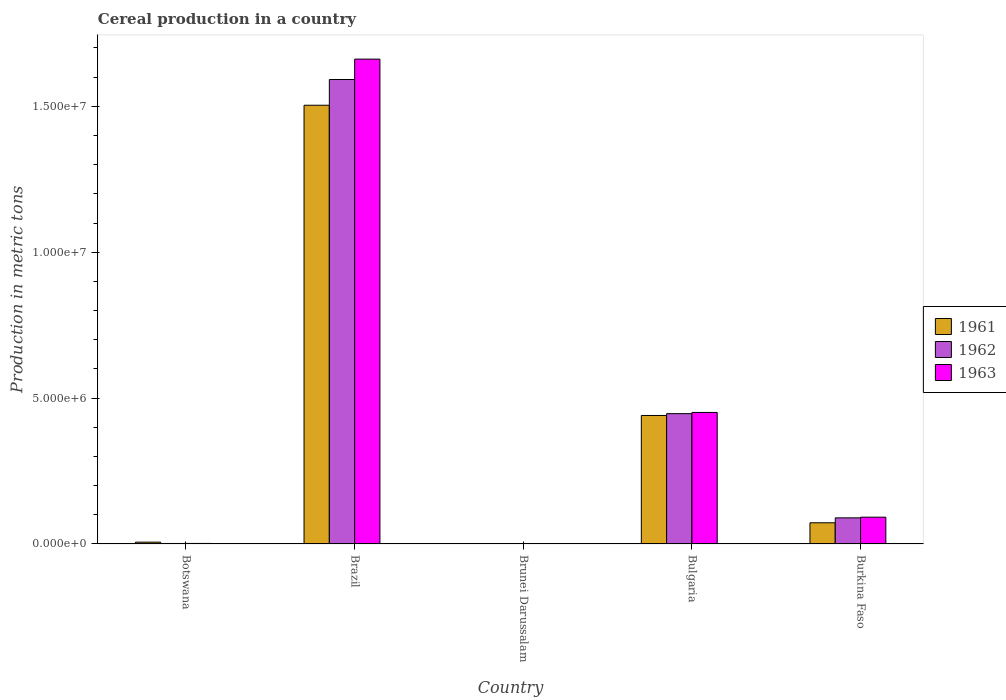Are the number of bars per tick equal to the number of legend labels?
Your response must be concise. Yes. Are the number of bars on each tick of the X-axis equal?
Offer a terse response. Yes. What is the label of the 5th group of bars from the left?
Keep it short and to the point. Burkina Faso. What is the total cereal production in 1963 in Brunei Darussalam?
Your answer should be very brief. 3868. Across all countries, what is the maximum total cereal production in 1962?
Offer a very short reply. 1.59e+07. Across all countries, what is the minimum total cereal production in 1962?
Ensure brevity in your answer.  5245. In which country was the total cereal production in 1963 minimum?
Your answer should be compact. Brunei Darussalam. What is the total total cereal production in 1961 in the graph?
Ensure brevity in your answer.  2.02e+07. What is the difference between the total cereal production in 1961 in Brazil and that in Bulgaria?
Provide a succinct answer. 1.06e+07. What is the difference between the total cereal production in 1962 in Burkina Faso and the total cereal production in 1961 in Brazil?
Your answer should be very brief. -1.41e+07. What is the average total cereal production in 1961 per country?
Your answer should be compact. 4.05e+06. What is the difference between the total cereal production of/in 1962 and total cereal production of/in 1961 in Brunei Darussalam?
Your answer should be very brief. 337. In how many countries, is the total cereal production in 1962 greater than 9000000 metric tons?
Provide a succinct answer. 1. What is the ratio of the total cereal production in 1963 in Botswana to that in Brazil?
Your answer should be very brief. 0. Is the difference between the total cereal production in 1962 in Brunei Darussalam and Burkina Faso greater than the difference between the total cereal production in 1961 in Brunei Darussalam and Burkina Faso?
Offer a very short reply. No. What is the difference between the highest and the second highest total cereal production in 1963?
Ensure brevity in your answer.  3.59e+06. What is the difference between the highest and the lowest total cereal production in 1961?
Make the answer very short. 1.50e+07. Is the sum of the total cereal production in 1962 in Brunei Darussalam and Bulgaria greater than the maximum total cereal production in 1961 across all countries?
Ensure brevity in your answer.  No. What does the 3rd bar from the left in Botswana represents?
Offer a terse response. 1963. How many countries are there in the graph?
Offer a very short reply. 5. What is the difference between two consecutive major ticks on the Y-axis?
Offer a very short reply. 5.00e+06. Are the values on the major ticks of Y-axis written in scientific E-notation?
Give a very brief answer. Yes. Where does the legend appear in the graph?
Your answer should be compact. Center right. How many legend labels are there?
Your answer should be very brief. 3. What is the title of the graph?
Provide a succinct answer. Cereal production in a country. Does "2004" appear as one of the legend labels in the graph?
Offer a very short reply. No. What is the label or title of the X-axis?
Provide a succinct answer. Country. What is the label or title of the Y-axis?
Your answer should be compact. Production in metric tons. What is the Production in metric tons of 1961 in Botswana?
Provide a succinct answer. 6.22e+04. What is the Production in metric tons in 1962 in Botswana?
Make the answer very short. 1.69e+04. What is the Production in metric tons in 1963 in Botswana?
Your response must be concise. 1.86e+04. What is the Production in metric tons of 1961 in Brazil?
Offer a terse response. 1.50e+07. What is the Production in metric tons in 1962 in Brazil?
Provide a succinct answer. 1.59e+07. What is the Production in metric tons in 1963 in Brazil?
Give a very brief answer. 1.66e+07. What is the Production in metric tons of 1961 in Brunei Darussalam?
Give a very brief answer. 4908. What is the Production in metric tons of 1962 in Brunei Darussalam?
Your answer should be compact. 5245. What is the Production in metric tons in 1963 in Brunei Darussalam?
Provide a short and direct response. 3868. What is the Production in metric tons of 1961 in Bulgaria?
Keep it short and to the point. 4.40e+06. What is the Production in metric tons in 1962 in Bulgaria?
Offer a very short reply. 4.47e+06. What is the Production in metric tons in 1963 in Bulgaria?
Offer a terse response. 4.51e+06. What is the Production in metric tons of 1961 in Burkina Faso?
Provide a short and direct response. 7.26e+05. What is the Production in metric tons in 1962 in Burkina Faso?
Offer a very short reply. 8.95e+05. What is the Production in metric tons of 1963 in Burkina Faso?
Provide a succinct answer. 9.18e+05. Across all countries, what is the maximum Production in metric tons in 1961?
Your answer should be compact. 1.50e+07. Across all countries, what is the maximum Production in metric tons in 1962?
Provide a short and direct response. 1.59e+07. Across all countries, what is the maximum Production in metric tons in 1963?
Offer a terse response. 1.66e+07. Across all countries, what is the minimum Production in metric tons of 1961?
Your response must be concise. 4908. Across all countries, what is the minimum Production in metric tons in 1962?
Provide a succinct answer. 5245. Across all countries, what is the minimum Production in metric tons in 1963?
Your answer should be very brief. 3868. What is the total Production in metric tons of 1961 in the graph?
Offer a very short reply. 2.02e+07. What is the total Production in metric tons in 1962 in the graph?
Make the answer very short. 2.13e+07. What is the total Production in metric tons in 1963 in the graph?
Offer a very short reply. 2.21e+07. What is the difference between the Production in metric tons in 1961 in Botswana and that in Brazil?
Offer a very short reply. -1.50e+07. What is the difference between the Production in metric tons in 1962 in Botswana and that in Brazil?
Ensure brevity in your answer.  -1.59e+07. What is the difference between the Production in metric tons of 1963 in Botswana and that in Brazil?
Your response must be concise. -1.66e+07. What is the difference between the Production in metric tons in 1961 in Botswana and that in Brunei Darussalam?
Make the answer very short. 5.73e+04. What is the difference between the Production in metric tons of 1962 in Botswana and that in Brunei Darussalam?
Your answer should be compact. 1.17e+04. What is the difference between the Production in metric tons of 1963 in Botswana and that in Brunei Darussalam?
Ensure brevity in your answer.  1.47e+04. What is the difference between the Production in metric tons of 1961 in Botswana and that in Bulgaria?
Provide a short and direct response. -4.34e+06. What is the difference between the Production in metric tons of 1962 in Botswana and that in Bulgaria?
Offer a terse response. -4.45e+06. What is the difference between the Production in metric tons of 1963 in Botswana and that in Bulgaria?
Provide a succinct answer. -4.49e+06. What is the difference between the Production in metric tons of 1961 in Botswana and that in Burkina Faso?
Provide a short and direct response. -6.64e+05. What is the difference between the Production in metric tons in 1962 in Botswana and that in Burkina Faso?
Ensure brevity in your answer.  -8.78e+05. What is the difference between the Production in metric tons in 1963 in Botswana and that in Burkina Faso?
Your answer should be compact. -9.00e+05. What is the difference between the Production in metric tons in 1961 in Brazil and that in Brunei Darussalam?
Offer a terse response. 1.50e+07. What is the difference between the Production in metric tons in 1962 in Brazil and that in Brunei Darussalam?
Offer a terse response. 1.59e+07. What is the difference between the Production in metric tons in 1963 in Brazil and that in Brunei Darussalam?
Make the answer very short. 1.66e+07. What is the difference between the Production in metric tons of 1961 in Brazil and that in Bulgaria?
Your answer should be compact. 1.06e+07. What is the difference between the Production in metric tons in 1962 in Brazil and that in Bulgaria?
Your answer should be compact. 1.15e+07. What is the difference between the Production in metric tons in 1963 in Brazil and that in Bulgaria?
Ensure brevity in your answer.  1.21e+07. What is the difference between the Production in metric tons in 1961 in Brazil and that in Burkina Faso?
Provide a succinct answer. 1.43e+07. What is the difference between the Production in metric tons of 1962 in Brazil and that in Burkina Faso?
Your answer should be compact. 1.50e+07. What is the difference between the Production in metric tons of 1963 in Brazil and that in Burkina Faso?
Your answer should be compact. 1.57e+07. What is the difference between the Production in metric tons in 1961 in Brunei Darussalam and that in Bulgaria?
Offer a terse response. -4.40e+06. What is the difference between the Production in metric tons in 1962 in Brunei Darussalam and that in Bulgaria?
Offer a terse response. -4.46e+06. What is the difference between the Production in metric tons of 1963 in Brunei Darussalam and that in Bulgaria?
Give a very brief answer. -4.50e+06. What is the difference between the Production in metric tons of 1961 in Brunei Darussalam and that in Burkina Faso?
Keep it short and to the point. -7.21e+05. What is the difference between the Production in metric tons in 1962 in Brunei Darussalam and that in Burkina Faso?
Make the answer very short. -8.90e+05. What is the difference between the Production in metric tons in 1963 in Brunei Darussalam and that in Burkina Faso?
Your answer should be very brief. -9.14e+05. What is the difference between the Production in metric tons of 1961 in Bulgaria and that in Burkina Faso?
Offer a very short reply. 3.68e+06. What is the difference between the Production in metric tons of 1962 in Bulgaria and that in Burkina Faso?
Your response must be concise. 3.57e+06. What is the difference between the Production in metric tons in 1963 in Bulgaria and that in Burkina Faso?
Keep it short and to the point. 3.59e+06. What is the difference between the Production in metric tons of 1961 in Botswana and the Production in metric tons of 1962 in Brazil?
Ensure brevity in your answer.  -1.59e+07. What is the difference between the Production in metric tons in 1961 in Botswana and the Production in metric tons in 1963 in Brazil?
Give a very brief answer. -1.66e+07. What is the difference between the Production in metric tons of 1962 in Botswana and the Production in metric tons of 1963 in Brazil?
Give a very brief answer. -1.66e+07. What is the difference between the Production in metric tons in 1961 in Botswana and the Production in metric tons in 1962 in Brunei Darussalam?
Make the answer very short. 5.69e+04. What is the difference between the Production in metric tons in 1961 in Botswana and the Production in metric tons in 1963 in Brunei Darussalam?
Provide a succinct answer. 5.83e+04. What is the difference between the Production in metric tons of 1962 in Botswana and the Production in metric tons of 1963 in Brunei Darussalam?
Offer a very short reply. 1.30e+04. What is the difference between the Production in metric tons of 1961 in Botswana and the Production in metric tons of 1962 in Bulgaria?
Ensure brevity in your answer.  -4.40e+06. What is the difference between the Production in metric tons in 1961 in Botswana and the Production in metric tons in 1963 in Bulgaria?
Provide a succinct answer. -4.45e+06. What is the difference between the Production in metric tons in 1962 in Botswana and the Production in metric tons in 1963 in Bulgaria?
Your answer should be compact. -4.49e+06. What is the difference between the Production in metric tons in 1961 in Botswana and the Production in metric tons in 1962 in Burkina Faso?
Provide a short and direct response. -8.33e+05. What is the difference between the Production in metric tons in 1961 in Botswana and the Production in metric tons in 1963 in Burkina Faso?
Ensure brevity in your answer.  -8.56e+05. What is the difference between the Production in metric tons of 1962 in Botswana and the Production in metric tons of 1963 in Burkina Faso?
Ensure brevity in your answer.  -9.01e+05. What is the difference between the Production in metric tons in 1961 in Brazil and the Production in metric tons in 1962 in Brunei Darussalam?
Keep it short and to the point. 1.50e+07. What is the difference between the Production in metric tons in 1961 in Brazil and the Production in metric tons in 1963 in Brunei Darussalam?
Your answer should be compact. 1.50e+07. What is the difference between the Production in metric tons in 1962 in Brazil and the Production in metric tons in 1963 in Brunei Darussalam?
Give a very brief answer. 1.59e+07. What is the difference between the Production in metric tons in 1961 in Brazil and the Production in metric tons in 1962 in Bulgaria?
Ensure brevity in your answer.  1.06e+07. What is the difference between the Production in metric tons in 1961 in Brazil and the Production in metric tons in 1963 in Bulgaria?
Offer a very short reply. 1.05e+07. What is the difference between the Production in metric tons of 1962 in Brazil and the Production in metric tons of 1963 in Bulgaria?
Provide a short and direct response. 1.14e+07. What is the difference between the Production in metric tons in 1961 in Brazil and the Production in metric tons in 1962 in Burkina Faso?
Ensure brevity in your answer.  1.41e+07. What is the difference between the Production in metric tons of 1961 in Brazil and the Production in metric tons of 1963 in Burkina Faso?
Make the answer very short. 1.41e+07. What is the difference between the Production in metric tons of 1962 in Brazil and the Production in metric tons of 1963 in Burkina Faso?
Your answer should be very brief. 1.50e+07. What is the difference between the Production in metric tons of 1961 in Brunei Darussalam and the Production in metric tons of 1962 in Bulgaria?
Make the answer very short. -4.46e+06. What is the difference between the Production in metric tons in 1961 in Brunei Darussalam and the Production in metric tons in 1963 in Bulgaria?
Provide a succinct answer. -4.50e+06. What is the difference between the Production in metric tons in 1962 in Brunei Darussalam and the Production in metric tons in 1963 in Bulgaria?
Offer a terse response. -4.50e+06. What is the difference between the Production in metric tons of 1961 in Brunei Darussalam and the Production in metric tons of 1962 in Burkina Faso?
Keep it short and to the point. -8.90e+05. What is the difference between the Production in metric tons in 1961 in Brunei Darussalam and the Production in metric tons in 1963 in Burkina Faso?
Provide a succinct answer. -9.13e+05. What is the difference between the Production in metric tons of 1962 in Brunei Darussalam and the Production in metric tons of 1963 in Burkina Faso?
Provide a short and direct response. -9.13e+05. What is the difference between the Production in metric tons in 1961 in Bulgaria and the Production in metric tons in 1962 in Burkina Faso?
Provide a succinct answer. 3.51e+06. What is the difference between the Production in metric tons of 1961 in Bulgaria and the Production in metric tons of 1963 in Burkina Faso?
Offer a very short reply. 3.49e+06. What is the difference between the Production in metric tons in 1962 in Bulgaria and the Production in metric tons in 1963 in Burkina Faso?
Your answer should be compact. 3.55e+06. What is the average Production in metric tons of 1961 per country?
Offer a very short reply. 4.05e+06. What is the average Production in metric tons of 1962 per country?
Offer a terse response. 4.26e+06. What is the average Production in metric tons of 1963 per country?
Offer a very short reply. 4.41e+06. What is the difference between the Production in metric tons in 1961 and Production in metric tons in 1962 in Botswana?
Offer a terse response. 4.53e+04. What is the difference between the Production in metric tons of 1961 and Production in metric tons of 1963 in Botswana?
Provide a succinct answer. 4.36e+04. What is the difference between the Production in metric tons of 1962 and Production in metric tons of 1963 in Botswana?
Give a very brief answer. -1650. What is the difference between the Production in metric tons in 1961 and Production in metric tons in 1962 in Brazil?
Keep it short and to the point. -8.82e+05. What is the difference between the Production in metric tons of 1961 and Production in metric tons of 1963 in Brazil?
Keep it short and to the point. -1.58e+06. What is the difference between the Production in metric tons in 1962 and Production in metric tons in 1963 in Brazil?
Your response must be concise. -6.99e+05. What is the difference between the Production in metric tons in 1961 and Production in metric tons in 1962 in Brunei Darussalam?
Offer a terse response. -337. What is the difference between the Production in metric tons in 1961 and Production in metric tons in 1963 in Brunei Darussalam?
Offer a very short reply. 1040. What is the difference between the Production in metric tons of 1962 and Production in metric tons of 1963 in Brunei Darussalam?
Provide a succinct answer. 1377. What is the difference between the Production in metric tons of 1961 and Production in metric tons of 1962 in Bulgaria?
Ensure brevity in your answer.  -6.24e+04. What is the difference between the Production in metric tons in 1961 and Production in metric tons in 1963 in Bulgaria?
Provide a succinct answer. -1.04e+05. What is the difference between the Production in metric tons in 1962 and Production in metric tons in 1963 in Bulgaria?
Offer a terse response. -4.12e+04. What is the difference between the Production in metric tons in 1961 and Production in metric tons in 1962 in Burkina Faso?
Make the answer very short. -1.69e+05. What is the difference between the Production in metric tons of 1961 and Production in metric tons of 1963 in Burkina Faso?
Make the answer very short. -1.92e+05. What is the difference between the Production in metric tons in 1962 and Production in metric tons in 1963 in Burkina Faso?
Make the answer very short. -2.31e+04. What is the ratio of the Production in metric tons in 1961 in Botswana to that in Brazil?
Your response must be concise. 0. What is the ratio of the Production in metric tons of 1962 in Botswana to that in Brazil?
Ensure brevity in your answer.  0. What is the ratio of the Production in metric tons in 1963 in Botswana to that in Brazil?
Offer a terse response. 0. What is the ratio of the Production in metric tons in 1961 in Botswana to that in Brunei Darussalam?
Provide a succinct answer. 12.67. What is the ratio of the Production in metric tons of 1962 in Botswana to that in Brunei Darussalam?
Your response must be concise. 3.22. What is the ratio of the Production in metric tons in 1963 in Botswana to that in Brunei Darussalam?
Keep it short and to the point. 4.8. What is the ratio of the Production in metric tons of 1961 in Botswana to that in Bulgaria?
Make the answer very short. 0.01. What is the ratio of the Production in metric tons of 1962 in Botswana to that in Bulgaria?
Make the answer very short. 0. What is the ratio of the Production in metric tons in 1963 in Botswana to that in Bulgaria?
Offer a terse response. 0. What is the ratio of the Production in metric tons in 1961 in Botswana to that in Burkina Faso?
Your answer should be very brief. 0.09. What is the ratio of the Production in metric tons of 1962 in Botswana to that in Burkina Faso?
Make the answer very short. 0.02. What is the ratio of the Production in metric tons in 1963 in Botswana to that in Burkina Faso?
Provide a succinct answer. 0.02. What is the ratio of the Production in metric tons in 1961 in Brazil to that in Brunei Darussalam?
Your answer should be compact. 3063.64. What is the ratio of the Production in metric tons of 1962 in Brazil to that in Brunei Darussalam?
Your answer should be very brief. 3034.95. What is the ratio of the Production in metric tons of 1963 in Brazil to that in Brunei Darussalam?
Make the answer very short. 4295.99. What is the ratio of the Production in metric tons in 1961 in Brazil to that in Bulgaria?
Make the answer very short. 3.41. What is the ratio of the Production in metric tons of 1962 in Brazil to that in Bulgaria?
Give a very brief answer. 3.56. What is the ratio of the Production in metric tons of 1963 in Brazil to that in Bulgaria?
Make the answer very short. 3.69. What is the ratio of the Production in metric tons of 1961 in Brazil to that in Burkina Faso?
Offer a very short reply. 20.71. What is the ratio of the Production in metric tons in 1962 in Brazil to that in Burkina Faso?
Ensure brevity in your answer.  17.78. What is the ratio of the Production in metric tons in 1963 in Brazil to that in Burkina Faso?
Ensure brevity in your answer.  18.1. What is the ratio of the Production in metric tons of 1961 in Brunei Darussalam to that in Bulgaria?
Your answer should be compact. 0. What is the ratio of the Production in metric tons in 1962 in Brunei Darussalam to that in Bulgaria?
Offer a terse response. 0. What is the ratio of the Production in metric tons of 1963 in Brunei Darussalam to that in Bulgaria?
Ensure brevity in your answer.  0. What is the ratio of the Production in metric tons of 1961 in Brunei Darussalam to that in Burkina Faso?
Your response must be concise. 0.01. What is the ratio of the Production in metric tons of 1962 in Brunei Darussalam to that in Burkina Faso?
Make the answer very short. 0.01. What is the ratio of the Production in metric tons of 1963 in Brunei Darussalam to that in Burkina Faso?
Make the answer very short. 0. What is the ratio of the Production in metric tons of 1961 in Bulgaria to that in Burkina Faso?
Give a very brief answer. 6.07. What is the ratio of the Production in metric tons of 1962 in Bulgaria to that in Burkina Faso?
Keep it short and to the point. 4.99. What is the ratio of the Production in metric tons in 1963 in Bulgaria to that in Burkina Faso?
Your answer should be compact. 4.91. What is the difference between the highest and the second highest Production in metric tons of 1961?
Give a very brief answer. 1.06e+07. What is the difference between the highest and the second highest Production in metric tons of 1962?
Provide a short and direct response. 1.15e+07. What is the difference between the highest and the second highest Production in metric tons of 1963?
Offer a very short reply. 1.21e+07. What is the difference between the highest and the lowest Production in metric tons in 1961?
Make the answer very short. 1.50e+07. What is the difference between the highest and the lowest Production in metric tons in 1962?
Your answer should be compact. 1.59e+07. What is the difference between the highest and the lowest Production in metric tons of 1963?
Keep it short and to the point. 1.66e+07. 